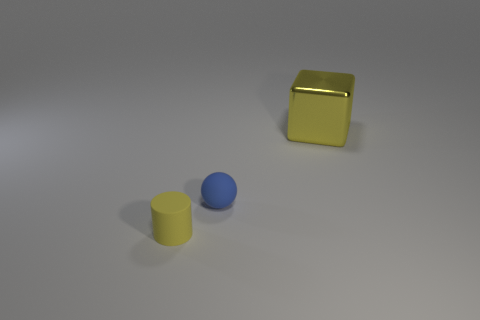Is there any other thing that has the same material as the large cube?
Offer a very short reply. No. What number of matte cylinders are the same size as the yellow block?
Your response must be concise. 0. What number of things are yellow objects behind the small yellow rubber cylinder or yellow objects that are left of the shiny block?
Your response must be concise. 2. Does the metallic object have the same shape as the rubber thing behind the small cylinder?
Offer a terse response. No. There is a rubber object that is behind the matte object that is to the left of the rubber thing right of the yellow matte cylinder; what is its shape?
Ensure brevity in your answer.  Sphere. What number of other things are there of the same material as the small yellow object
Provide a succinct answer. 1. How many things are either small things that are behind the small yellow matte thing or big yellow things?
Provide a short and direct response. 2. What is the shape of the tiny thing right of the yellow object that is left of the yellow shiny thing?
Your answer should be compact. Sphere. Does the yellow object right of the blue sphere have the same shape as the tiny blue rubber object?
Your answer should be very brief. No. What is the color of the tiny thing to the left of the blue sphere?
Your response must be concise. Yellow. 